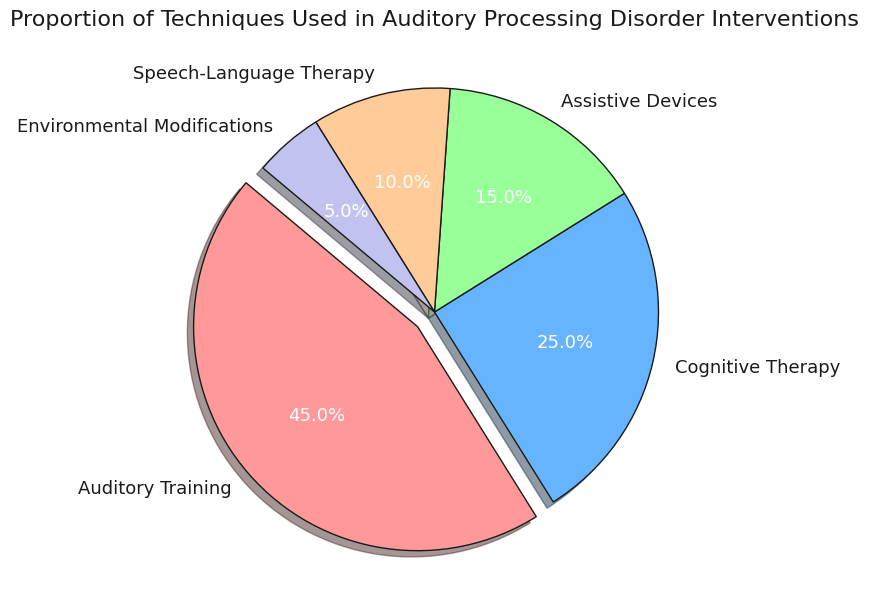Which technique is used the most in auditory processing disorder interventions? The figure shows five techniques with their corresponding proportions. The largest slice of the pie chart represents Auditory Training with 45%.
Answer: Auditory Training What percentage of the interventions are Cognitive Therapy and Assistive Devices combined? Cognitive Therapy is 25% and Assistive Devices is 15%. Adding these percentages together gives 25% + 15% = 40%.
Answer: 40% Is the proportion of Auditory Training greater than the combined proportion of Speech-Language Therapy and Environmental Modifications? Auditory Training is 45%. Speech-Language Therapy is 10% and Environmental Modifications are 5%. Adding these gives 10% + 5% = 15%, which is less than 45%.
Answer: Yes Which technique has the smallest proportion in the interventions? The pie chart shows that Environmental Modifications have the smallest slice, which corresponds to 5%.
Answer: Environmental Modifications What is the difference in proportion between Auditory Training and Cognitive Therapy? Auditory Training is 45% and Cognitive Therapy is 25%. The difference is 45% - 25% = 20%.
Answer: 20% What colors are used to represent Cognitive Therapy and Assistive Devices in the pie chart? The figure uses blue for Cognitive Therapy and green for Assistive Devices.
Answer: Blue (Cognitive Therapy), Green (Assistive Devices) What is the proportion of interventions not involving Auditory Training? The proportion of Auditory Training is 45%. Subtracting this from 100% gives 100% - 45% = 55%.
Answer: 55% How many techniques have a proportion less than 20%? Assistive Devices are 15%, Speech-Language Therapy is 10%, and Environmental Modifications are 5%. These three techniques all have proportions less than 20%.
Answer: Three Is the proportion of Cognitive Therapy equal to twice the proportion of Assistive Devices? Cognitive Therapy is 25%, and twice the proportion of Assistive Devices is 2 * 15% = 30%, which is not equal.
Answer: No 